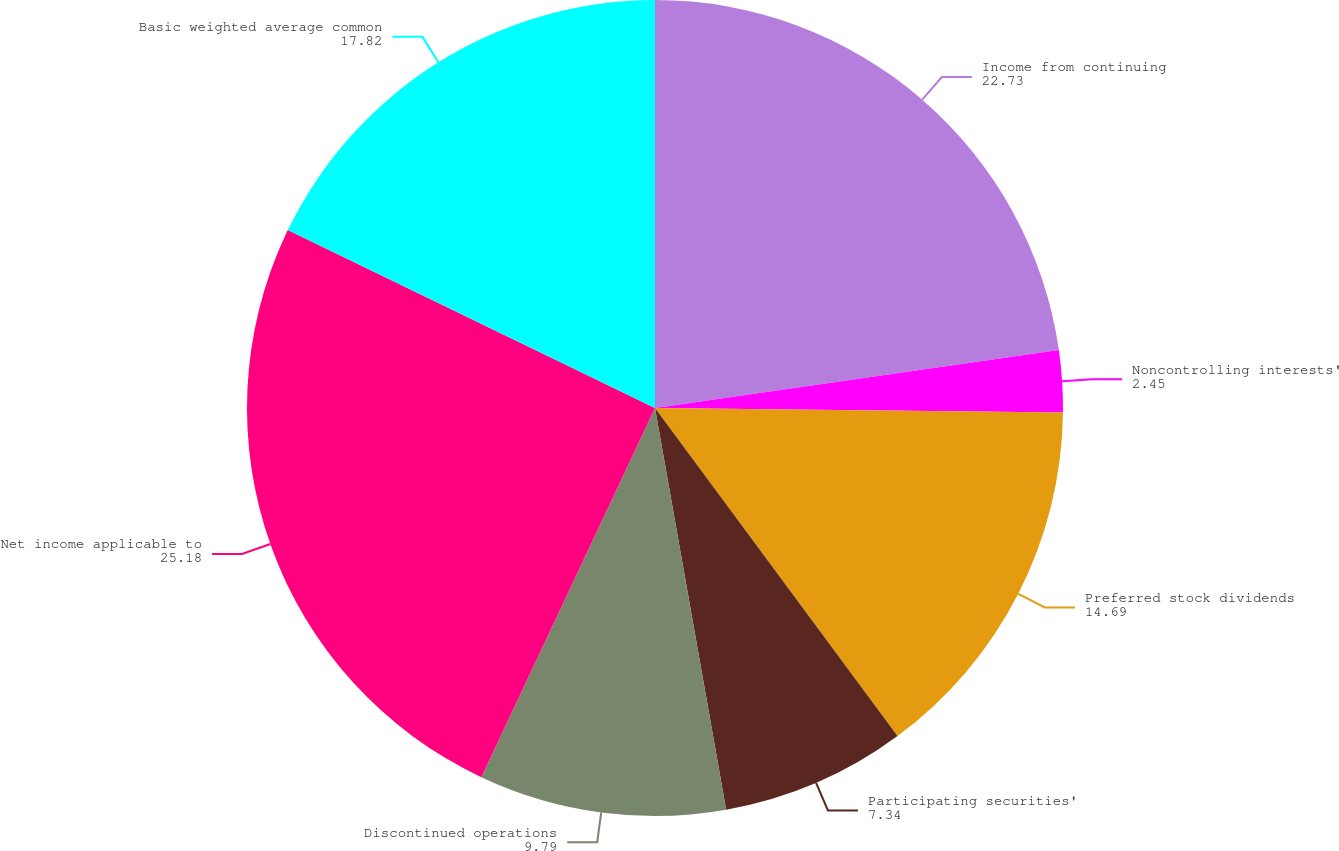Convert chart. <chart><loc_0><loc_0><loc_500><loc_500><pie_chart><fcel>Income from continuing<fcel>Noncontrolling interests'<fcel>Preferred stock dividends<fcel>Participating securities'<fcel>Discontinued operations<fcel>Net income applicable to<fcel>Basic weighted average common<nl><fcel>22.73%<fcel>2.45%<fcel>14.69%<fcel>7.34%<fcel>9.79%<fcel>25.18%<fcel>17.82%<nl></chart> 